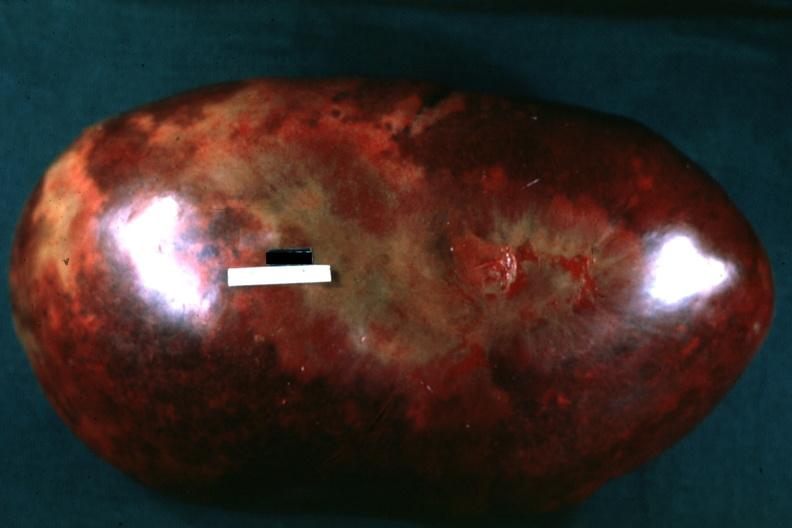s cryptosporidia present?
Answer the question using a single word or phrase. No 